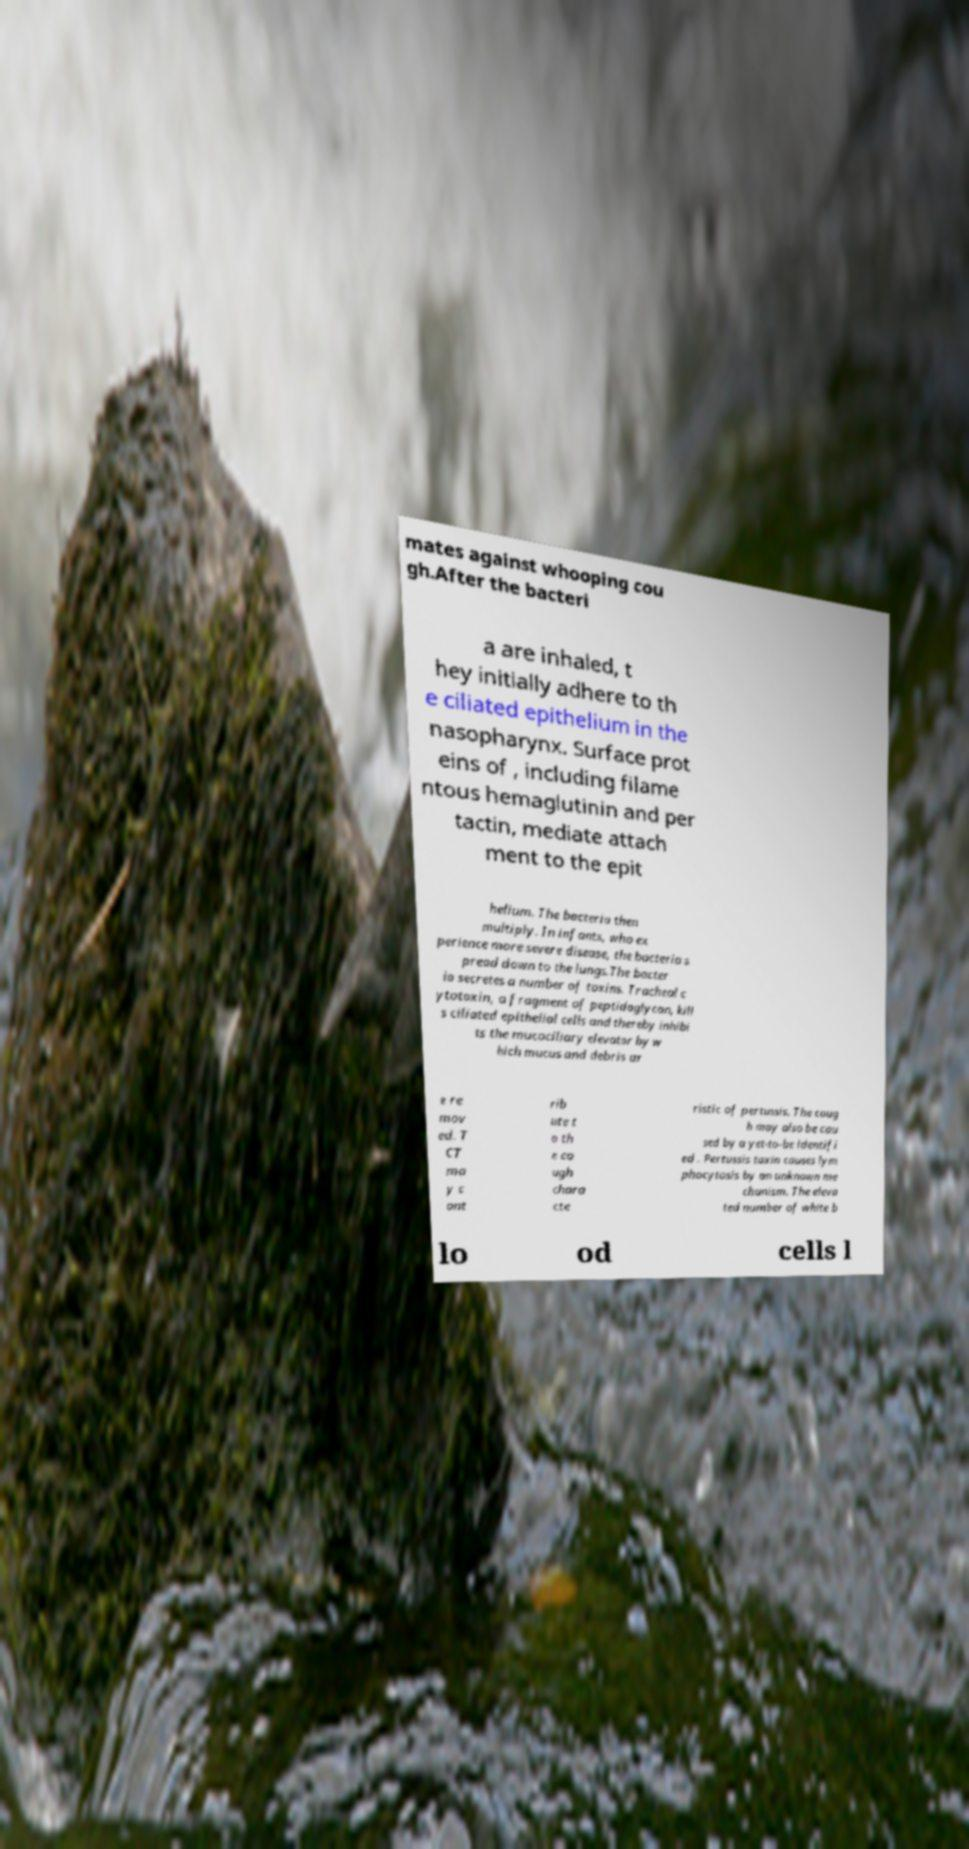For documentation purposes, I need the text within this image transcribed. Could you provide that? mates against whooping cou gh.After the bacteri a are inhaled, t hey initially adhere to th e ciliated epithelium in the nasopharynx. Surface prot eins of , including filame ntous hemaglutinin and per tactin, mediate attach ment to the epit helium. The bacteria then multiply. In infants, who ex perience more severe disease, the bacteria s pread down to the lungs.The bacter ia secretes a number of toxins. Tracheal c ytotoxin, a fragment of peptidoglycan, kill s ciliated epithelial cells and thereby inhibi ts the mucociliary elevator by w hich mucus and debris ar e re mov ed. T CT ma y c ont rib ute t o th e co ugh chara cte ristic of pertussis. The coug h may also be cau sed by a yet-to-be identifi ed . Pertussis toxin causes lym phocytosis by an unknown me chanism. The eleva ted number of white b lo od cells l 